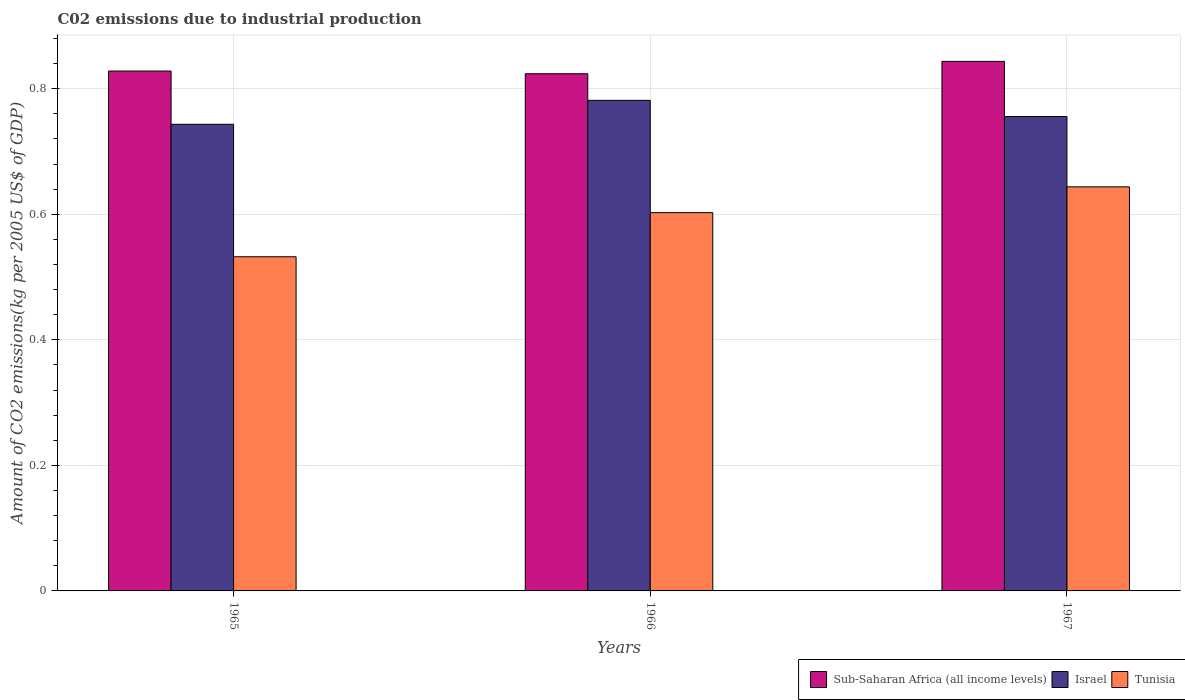How many different coloured bars are there?
Keep it short and to the point. 3. Are the number of bars per tick equal to the number of legend labels?
Make the answer very short. Yes. Are the number of bars on each tick of the X-axis equal?
Your answer should be very brief. Yes. How many bars are there on the 1st tick from the left?
Keep it short and to the point. 3. How many bars are there on the 3rd tick from the right?
Your answer should be compact. 3. What is the label of the 1st group of bars from the left?
Ensure brevity in your answer.  1965. In how many cases, is the number of bars for a given year not equal to the number of legend labels?
Give a very brief answer. 0. What is the amount of CO2 emitted due to industrial production in Tunisia in 1966?
Keep it short and to the point. 0.6. Across all years, what is the maximum amount of CO2 emitted due to industrial production in Sub-Saharan Africa (all income levels)?
Keep it short and to the point. 0.84. Across all years, what is the minimum amount of CO2 emitted due to industrial production in Tunisia?
Provide a short and direct response. 0.53. In which year was the amount of CO2 emitted due to industrial production in Israel maximum?
Make the answer very short. 1966. In which year was the amount of CO2 emitted due to industrial production in Sub-Saharan Africa (all income levels) minimum?
Keep it short and to the point. 1966. What is the total amount of CO2 emitted due to industrial production in Tunisia in the graph?
Make the answer very short. 1.78. What is the difference between the amount of CO2 emitted due to industrial production in Israel in 1965 and that in 1967?
Ensure brevity in your answer.  -0.01. What is the difference between the amount of CO2 emitted due to industrial production in Sub-Saharan Africa (all income levels) in 1965 and the amount of CO2 emitted due to industrial production in Tunisia in 1966?
Keep it short and to the point. 0.23. What is the average amount of CO2 emitted due to industrial production in Sub-Saharan Africa (all income levels) per year?
Offer a very short reply. 0.83. In the year 1965, what is the difference between the amount of CO2 emitted due to industrial production in Israel and amount of CO2 emitted due to industrial production in Tunisia?
Provide a succinct answer. 0.21. In how many years, is the amount of CO2 emitted due to industrial production in Sub-Saharan Africa (all income levels) greater than 0.12 kg?
Keep it short and to the point. 3. What is the ratio of the amount of CO2 emitted due to industrial production in Tunisia in 1965 to that in 1966?
Make the answer very short. 0.88. Is the amount of CO2 emitted due to industrial production in Israel in 1966 less than that in 1967?
Ensure brevity in your answer.  No. Is the difference between the amount of CO2 emitted due to industrial production in Israel in 1965 and 1967 greater than the difference between the amount of CO2 emitted due to industrial production in Tunisia in 1965 and 1967?
Your answer should be very brief. Yes. What is the difference between the highest and the second highest amount of CO2 emitted due to industrial production in Israel?
Your answer should be very brief. 0.03. What is the difference between the highest and the lowest amount of CO2 emitted due to industrial production in Israel?
Offer a very short reply. 0.04. In how many years, is the amount of CO2 emitted due to industrial production in Israel greater than the average amount of CO2 emitted due to industrial production in Israel taken over all years?
Your response must be concise. 1. Is the sum of the amount of CO2 emitted due to industrial production in Tunisia in 1966 and 1967 greater than the maximum amount of CO2 emitted due to industrial production in Israel across all years?
Offer a terse response. Yes. What does the 1st bar from the right in 1966 represents?
Give a very brief answer. Tunisia. Is it the case that in every year, the sum of the amount of CO2 emitted due to industrial production in Tunisia and amount of CO2 emitted due to industrial production in Israel is greater than the amount of CO2 emitted due to industrial production in Sub-Saharan Africa (all income levels)?
Make the answer very short. Yes. How many bars are there?
Keep it short and to the point. 9. How many years are there in the graph?
Provide a succinct answer. 3. What is the difference between two consecutive major ticks on the Y-axis?
Provide a succinct answer. 0.2. Are the values on the major ticks of Y-axis written in scientific E-notation?
Provide a short and direct response. No. Does the graph contain grids?
Make the answer very short. Yes. Where does the legend appear in the graph?
Provide a succinct answer. Bottom right. How are the legend labels stacked?
Offer a very short reply. Horizontal. What is the title of the graph?
Your response must be concise. C02 emissions due to industrial production. Does "Tonga" appear as one of the legend labels in the graph?
Your answer should be very brief. No. What is the label or title of the X-axis?
Your response must be concise. Years. What is the label or title of the Y-axis?
Give a very brief answer. Amount of CO2 emissions(kg per 2005 US$ of GDP). What is the Amount of CO2 emissions(kg per 2005 US$ of GDP) of Sub-Saharan Africa (all income levels) in 1965?
Give a very brief answer. 0.83. What is the Amount of CO2 emissions(kg per 2005 US$ of GDP) of Israel in 1965?
Offer a terse response. 0.74. What is the Amount of CO2 emissions(kg per 2005 US$ of GDP) of Tunisia in 1965?
Provide a succinct answer. 0.53. What is the Amount of CO2 emissions(kg per 2005 US$ of GDP) of Sub-Saharan Africa (all income levels) in 1966?
Provide a succinct answer. 0.82. What is the Amount of CO2 emissions(kg per 2005 US$ of GDP) in Israel in 1966?
Ensure brevity in your answer.  0.78. What is the Amount of CO2 emissions(kg per 2005 US$ of GDP) of Tunisia in 1966?
Offer a terse response. 0.6. What is the Amount of CO2 emissions(kg per 2005 US$ of GDP) of Sub-Saharan Africa (all income levels) in 1967?
Ensure brevity in your answer.  0.84. What is the Amount of CO2 emissions(kg per 2005 US$ of GDP) of Israel in 1967?
Provide a short and direct response. 0.76. What is the Amount of CO2 emissions(kg per 2005 US$ of GDP) of Tunisia in 1967?
Give a very brief answer. 0.64. Across all years, what is the maximum Amount of CO2 emissions(kg per 2005 US$ of GDP) of Sub-Saharan Africa (all income levels)?
Ensure brevity in your answer.  0.84. Across all years, what is the maximum Amount of CO2 emissions(kg per 2005 US$ of GDP) of Israel?
Keep it short and to the point. 0.78. Across all years, what is the maximum Amount of CO2 emissions(kg per 2005 US$ of GDP) in Tunisia?
Offer a terse response. 0.64. Across all years, what is the minimum Amount of CO2 emissions(kg per 2005 US$ of GDP) in Sub-Saharan Africa (all income levels)?
Your answer should be very brief. 0.82. Across all years, what is the minimum Amount of CO2 emissions(kg per 2005 US$ of GDP) in Israel?
Make the answer very short. 0.74. Across all years, what is the minimum Amount of CO2 emissions(kg per 2005 US$ of GDP) in Tunisia?
Make the answer very short. 0.53. What is the total Amount of CO2 emissions(kg per 2005 US$ of GDP) of Sub-Saharan Africa (all income levels) in the graph?
Your answer should be very brief. 2.5. What is the total Amount of CO2 emissions(kg per 2005 US$ of GDP) of Israel in the graph?
Provide a short and direct response. 2.28. What is the total Amount of CO2 emissions(kg per 2005 US$ of GDP) in Tunisia in the graph?
Your answer should be very brief. 1.78. What is the difference between the Amount of CO2 emissions(kg per 2005 US$ of GDP) of Sub-Saharan Africa (all income levels) in 1965 and that in 1966?
Keep it short and to the point. 0. What is the difference between the Amount of CO2 emissions(kg per 2005 US$ of GDP) in Israel in 1965 and that in 1966?
Provide a succinct answer. -0.04. What is the difference between the Amount of CO2 emissions(kg per 2005 US$ of GDP) in Tunisia in 1965 and that in 1966?
Your response must be concise. -0.07. What is the difference between the Amount of CO2 emissions(kg per 2005 US$ of GDP) of Sub-Saharan Africa (all income levels) in 1965 and that in 1967?
Keep it short and to the point. -0.02. What is the difference between the Amount of CO2 emissions(kg per 2005 US$ of GDP) of Israel in 1965 and that in 1967?
Keep it short and to the point. -0.01. What is the difference between the Amount of CO2 emissions(kg per 2005 US$ of GDP) in Tunisia in 1965 and that in 1967?
Your answer should be compact. -0.11. What is the difference between the Amount of CO2 emissions(kg per 2005 US$ of GDP) in Sub-Saharan Africa (all income levels) in 1966 and that in 1967?
Keep it short and to the point. -0.02. What is the difference between the Amount of CO2 emissions(kg per 2005 US$ of GDP) in Israel in 1966 and that in 1967?
Ensure brevity in your answer.  0.03. What is the difference between the Amount of CO2 emissions(kg per 2005 US$ of GDP) in Tunisia in 1966 and that in 1967?
Offer a terse response. -0.04. What is the difference between the Amount of CO2 emissions(kg per 2005 US$ of GDP) in Sub-Saharan Africa (all income levels) in 1965 and the Amount of CO2 emissions(kg per 2005 US$ of GDP) in Israel in 1966?
Your answer should be very brief. 0.05. What is the difference between the Amount of CO2 emissions(kg per 2005 US$ of GDP) of Sub-Saharan Africa (all income levels) in 1965 and the Amount of CO2 emissions(kg per 2005 US$ of GDP) of Tunisia in 1966?
Your response must be concise. 0.23. What is the difference between the Amount of CO2 emissions(kg per 2005 US$ of GDP) in Israel in 1965 and the Amount of CO2 emissions(kg per 2005 US$ of GDP) in Tunisia in 1966?
Ensure brevity in your answer.  0.14. What is the difference between the Amount of CO2 emissions(kg per 2005 US$ of GDP) in Sub-Saharan Africa (all income levels) in 1965 and the Amount of CO2 emissions(kg per 2005 US$ of GDP) in Israel in 1967?
Your response must be concise. 0.07. What is the difference between the Amount of CO2 emissions(kg per 2005 US$ of GDP) in Sub-Saharan Africa (all income levels) in 1965 and the Amount of CO2 emissions(kg per 2005 US$ of GDP) in Tunisia in 1967?
Ensure brevity in your answer.  0.18. What is the difference between the Amount of CO2 emissions(kg per 2005 US$ of GDP) of Israel in 1965 and the Amount of CO2 emissions(kg per 2005 US$ of GDP) of Tunisia in 1967?
Make the answer very short. 0.1. What is the difference between the Amount of CO2 emissions(kg per 2005 US$ of GDP) in Sub-Saharan Africa (all income levels) in 1966 and the Amount of CO2 emissions(kg per 2005 US$ of GDP) in Israel in 1967?
Your response must be concise. 0.07. What is the difference between the Amount of CO2 emissions(kg per 2005 US$ of GDP) in Sub-Saharan Africa (all income levels) in 1966 and the Amount of CO2 emissions(kg per 2005 US$ of GDP) in Tunisia in 1967?
Offer a very short reply. 0.18. What is the difference between the Amount of CO2 emissions(kg per 2005 US$ of GDP) in Israel in 1966 and the Amount of CO2 emissions(kg per 2005 US$ of GDP) in Tunisia in 1967?
Your response must be concise. 0.14. What is the average Amount of CO2 emissions(kg per 2005 US$ of GDP) in Sub-Saharan Africa (all income levels) per year?
Make the answer very short. 0.83. What is the average Amount of CO2 emissions(kg per 2005 US$ of GDP) in Israel per year?
Your answer should be compact. 0.76. What is the average Amount of CO2 emissions(kg per 2005 US$ of GDP) of Tunisia per year?
Your response must be concise. 0.59. In the year 1965, what is the difference between the Amount of CO2 emissions(kg per 2005 US$ of GDP) of Sub-Saharan Africa (all income levels) and Amount of CO2 emissions(kg per 2005 US$ of GDP) of Israel?
Keep it short and to the point. 0.08. In the year 1965, what is the difference between the Amount of CO2 emissions(kg per 2005 US$ of GDP) of Sub-Saharan Africa (all income levels) and Amount of CO2 emissions(kg per 2005 US$ of GDP) of Tunisia?
Your answer should be compact. 0.3. In the year 1965, what is the difference between the Amount of CO2 emissions(kg per 2005 US$ of GDP) of Israel and Amount of CO2 emissions(kg per 2005 US$ of GDP) of Tunisia?
Give a very brief answer. 0.21. In the year 1966, what is the difference between the Amount of CO2 emissions(kg per 2005 US$ of GDP) of Sub-Saharan Africa (all income levels) and Amount of CO2 emissions(kg per 2005 US$ of GDP) of Israel?
Your answer should be very brief. 0.04. In the year 1966, what is the difference between the Amount of CO2 emissions(kg per 2005 US$ of GDP) of Sub-Saharan Africa (all income levels) and Amount of CO2 emissions(kg per 2005 US$ of GDP) of Tunisia?
Provide a short and direct response. 0.22. In the year 1966, what is the difference between the Amount of CO2 emissions(kg per 2005 US$ of GDP) of Israel and Amount of CO2 emissions(kg per 2005 US$ of GDP) of Tunisia?
Make the answer very short. 0.18. In the year 1967, what is the difference between the Amount of CO2 emissions(kg per 2005 US$ of GDP) of Sub-Saharan Africa (all income levels) and Amount of CO2 emissions(kg per 2005 US$ of GDP) of Israel?
Your answer should be compact. 0.09. In the year 1967, what is the difference between the Amount of CO2 emissions(kg per 2005 US$ of GDP) in Sub-Saharan Africa (all income levels) and Amount of CO2 emissions(kg per 2005 US$ of GDP) in Tunisia?
Your response must be concise. 0.2. In the year 1967, what is the difference between the Amount of CO2 emissions(kg per 2005 US$ of GDP) of Israel and Amount of CO2 emissions(kg per 2005 US$ of GDP) of Tunisia?
Your answer should be very brief. 0.11. What is the ratio of the Amount of CO2 emissions(kg per 2005 US$ of GDP) of Israel in 1965 to that in 1966?
Offer a terse response. 0.95. What is the ratio of the Amount of CO2 emissions(kg per 2005 US$ of GDP) of Tunisia in 1965 to that in 1966?
Your answer should be very brief. 0.88. What is the ratio of the Amount of CO2 emissions(kg per 2005 US$ of GDP) of Sub-Saharan Africa (all income levels) in 1965 to that in 1967?
Make the answer very short. 0.98. What is the ratio of the Amount of CO2 emissions(kg per 2005 US$ of GDP) in Israel in 1965 to that in 1967?
Offer a very short reply. 0.98. What is the ratio of the Amount of CO2 emissions(kg per 2005 US$ of GDP) of Tunisia in 1965 to that in 1967?
Offer a terse response. 0.83. What is the ratio of the Amount of CO2 emissions(kg per 2005 US$ of GDP) of Sub-Saharan Africa (all income levels) in 1966 to that in 1967?
Ensure brevity in your answer.  0.98. What is the ratio of the Amount of CO2 emissions(kg per 2005 US$ of GDP) of Israel in 1966 to that in 1967?
Provide a succinct answer. 1.03. What is the ratio of the Amount of CO2 emissions(kg per 2005 US$ of GDP) of Tunisia in 1966 to that in 1967?
Make the answer very short. 0.94. What is the difference between the highest and the second highest Amount of CO2 emissions(kg per 2005 US$ of GDP) of Sub-Saharan Africa (all income levels)?
Make the answer very short. 0.02. What is the difference between the highest and the second highest Amount of CO2 emissions(kg per 2005 US$ of GDP) of Israel?
Ensure brevity in your answer.  0.03. What is the difference between the highest and the second highest Amount of CO2 emissions(kg per 2005 US$ of GDP) in Tunisia?
Provide a succinct answer. 0.04. What is the difference between the highest and the lowest Amount of CO2 emissions(kg per 2005 US$ of GDP) in Sub-Saharan Africa (all income levels)?
Provide a succinct answer. 0.02. What is the difference between the highest and the lowest Amount of CO2 emissions(kg per 2005 US$ of GDP) in Israel?
Ensure brevity in your answer.  0.04. What is the difference between the highest and the lowest Amount of CO2 emissions(kg per 2005 US$ of GDP) in Tunisia?
Give a very brief answer. 0.11. 